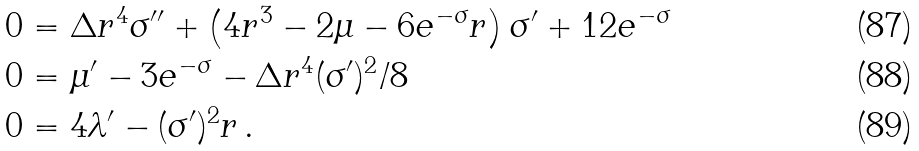Convert formula to latex. <formula><loc_0><loc_0><loc_500><loc_500>0 & = \Delta r ^ { 4 } \sigma ^ { \prime \prime } + \left ( 4 r ^ { 3 } - 2 \mu - 6 e ^ { - \sigma } r \right ) \sigma ^ { \prime } + 1 2 e ^ { - \sigma } \\ 0 & = \mu ^ { \prime } - 3 e ^ { - \sigma } - \Delta r ^ { 4 } ( \sigma ^ { \prime } ) ^ { 2 } / 8 \\ 0 & = 4 \lambda ^ { \prime } - ( \sigma ^ { \prime } ) ^ { 2 } r \, .</formula> 